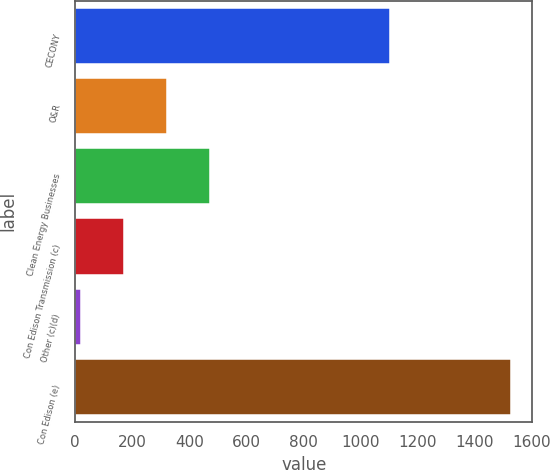Convert chart. <chart><loc_0><loc_0><loc_500><loc_500><bar_chart><fcel>CECONY<fcel>O&R<fcel>Clean Energy Businesses<fcel>Con Edison Transmission (c)<fcel>Other (c)(d)<fcel>Con Edison (e)<nl><fcel>1104<fcel>320.2<fcel>470.8<fcel>169.6<fcel>19<fcel>1525<nl></chart> 